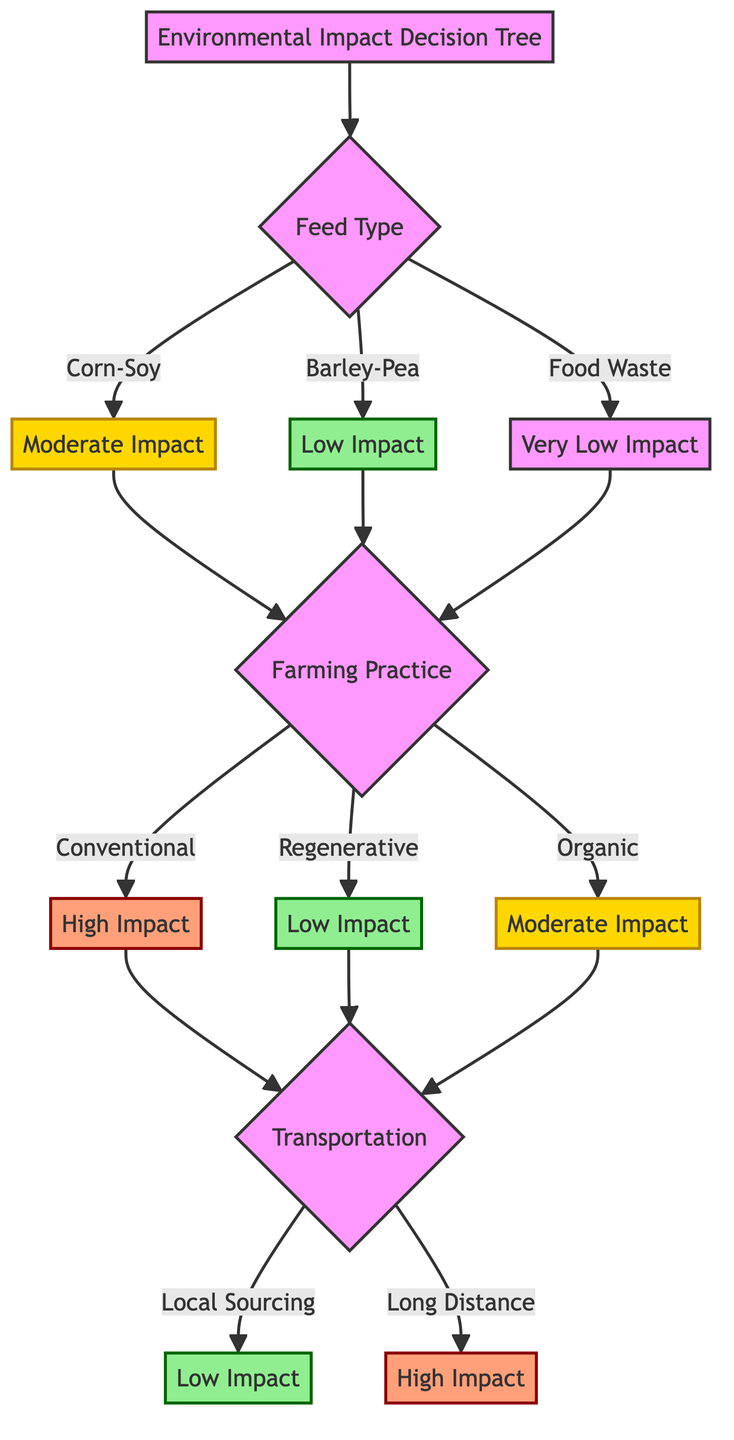What are the three feed types in the diagram? The diagram lists three feed types under the "Feed Type" decision node: Corn-Soy Feed, Barley-Pea Feed, and Food Waste Feed.
Answer: Corn-Soy Feed, Barley-Pea Feed, Food Waste Feed Which feed type has the lowest environmental impact? The diagram shows that Food Waste Feed has the environmental impact labeled as "Very Low," indicating it is the lowest among the three feed options.
Answer: Food Waste Feed What are the pros of Barley-Pea Feed? From the diagram, the pros listed for Barley-Pea Feed include "Lower water usage," "Reduced carbon footprint," and "Can be sourced locally."
Answer: Lower water usage, Reduced carbon footprint, Can be sourced locally What farming practice results in a "High" carbon footprint? According to the diagram, Conventional Farming leads to a "High" carbon footprint as it is connected to that level of impact.
Answer: Conventional Farming If a farmer chooses Food Waste Feed and Regenerative Farming, what will be the carbon footprint? Following the decision path in the diagram, Food Waste Feed leads to a low impact, and Regenerative Farming also leads to a low impact, so if both are chosen, the transportation impacts will dictate the resulting carbon footprint; thus, Local Sourcing would yield a "Low Impact."
Answer: Low Impact What is the relationship between local sourcing and carbon footprint? The diagram illustrates that Local Sourcing directly leads to a "Low" carbon footprint, indicating a positive impact on reducing transport emissions and supporting local economies.
Answer: Low Which combination of feed and transportation choice yields a "High" impact? The combination of Corn-Soy Feed with Long Distance Sourcing leads to a "High" impact as per the paths in the diagram.
Answer: Corn-Soy Feed with Long Distance Sourcing What are the cons of Organic Farming? The diagram specifies the cons of Organic Farming to be "Higher labor costs" and "Potentially lower yields."
Answer: Higher labor costs, Potentially lower yields What does the "Moderate" impact node correspond to in terms of farming practice? The "Moderate" impact node is linked to Organic Farming as per the decision flow in the diagram, indicating the environmental effects of this choice.
Answer: Organic Farming 